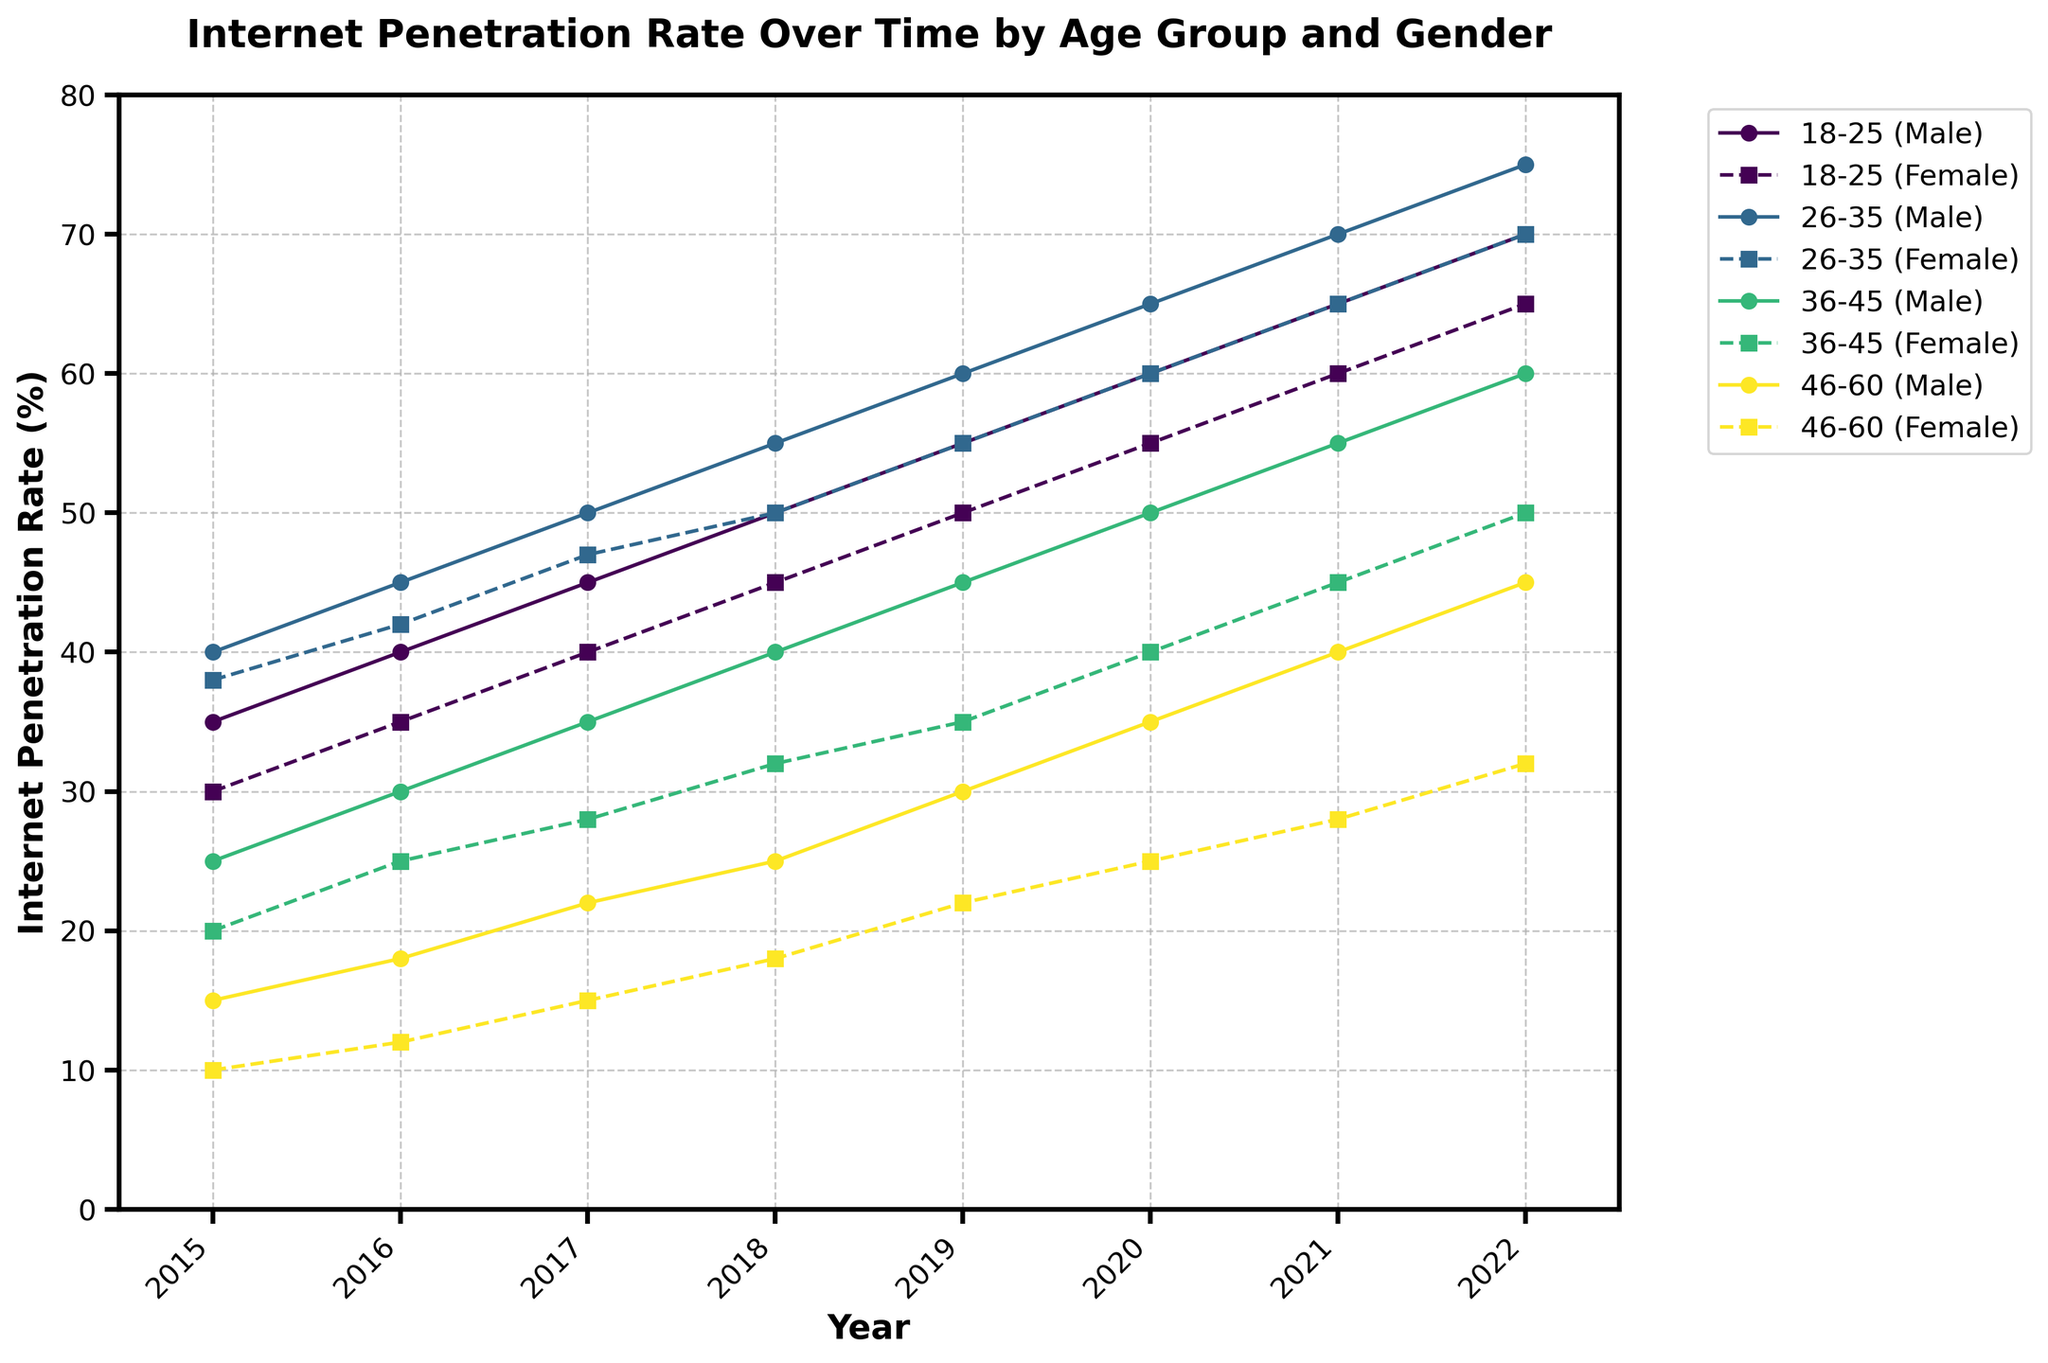What is the title of the figure? The title of the figure is prominently displayed at the top of the plot, showing the main theme of the data visualized.
Answer: Internet Penetration Rate Over Time by Age Group and Gender What do the axes represent? The axes represent the ranges and the labels of the data being visualized. The x-axis represents the years ranging from 2015 to 2022, and the y-axis represents the Internet Penetration Rate as a percentage.
Answer: The x-axis represents years, and the y-axis represents Internet Penetration Rate (%) How many age groups are represented in the figure? By looking at the unique markers and lines for each group, we can count the number of different age groups illustrated.
Answer: 4 Which age group and gender had the highest internet penetration rate in 2022? Look for the highest value on the y-axis in 2022 and identify the corresponding line color and marker. The age group 26-35 for males had the highest rate.
Answer: 26-35 (Male) What is the general trend of the Internet Penetration Rate for the age group 18-25? Observing the connected data points for the age group 18-25, we can infer whether the Internet Penetration Rate is increasing, decreasing, or remaining stable over time.
Answer: Increasing By how much did the Internet Penetration Rate change for females aged 46-60 from 2015 to 2022? Subtract the value in 2015 from the value in 2022 for the specified age group and gender. The rate increased from 10% in 2015 to 32% in 2022, a change of 22%.
Answer: 22% How do the rates for males and females aged 36-45 compare in 2021? Locate the data points for 2021 for both genders in the age group 36-45. Compare the y-axis values. Males had a rate of 55%, while females had 45%, so males were higher by 10%.
Answer: Males had a rate 10% higher than females What can be said about the internet penetration rate's growth for females aged 26-35 over the years? Examine the trend line for the given age group and gender to interpret the growth pattern. The rate shows a steady increase from 30% in 2015 to 70% in 2022.
Answer: Steady increase Which gender generally has higher internet penetration rates across the years in the age group 18-25? Compare the trend lines for males and females across all the years for the age group 18-25. Males consistently have higher rates.
Answer: Males Which year saw the largest increase in Internet Penetration for males aged 26-35? Look for the steepest part of the line for males aged 26-35 to identify the year with the largest increase. The biggest jump occurred between 2021 and 2022, from 70% to 75%.
Answer: 2021 to 2022 